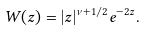Convert formula to latex. <formula><loc_0><loc_0><loc_500><loc_500>W ( z ) = | z | ^ { \nu + { 1 } / { 2 } } e ^ { - 2 z } .</formula> 